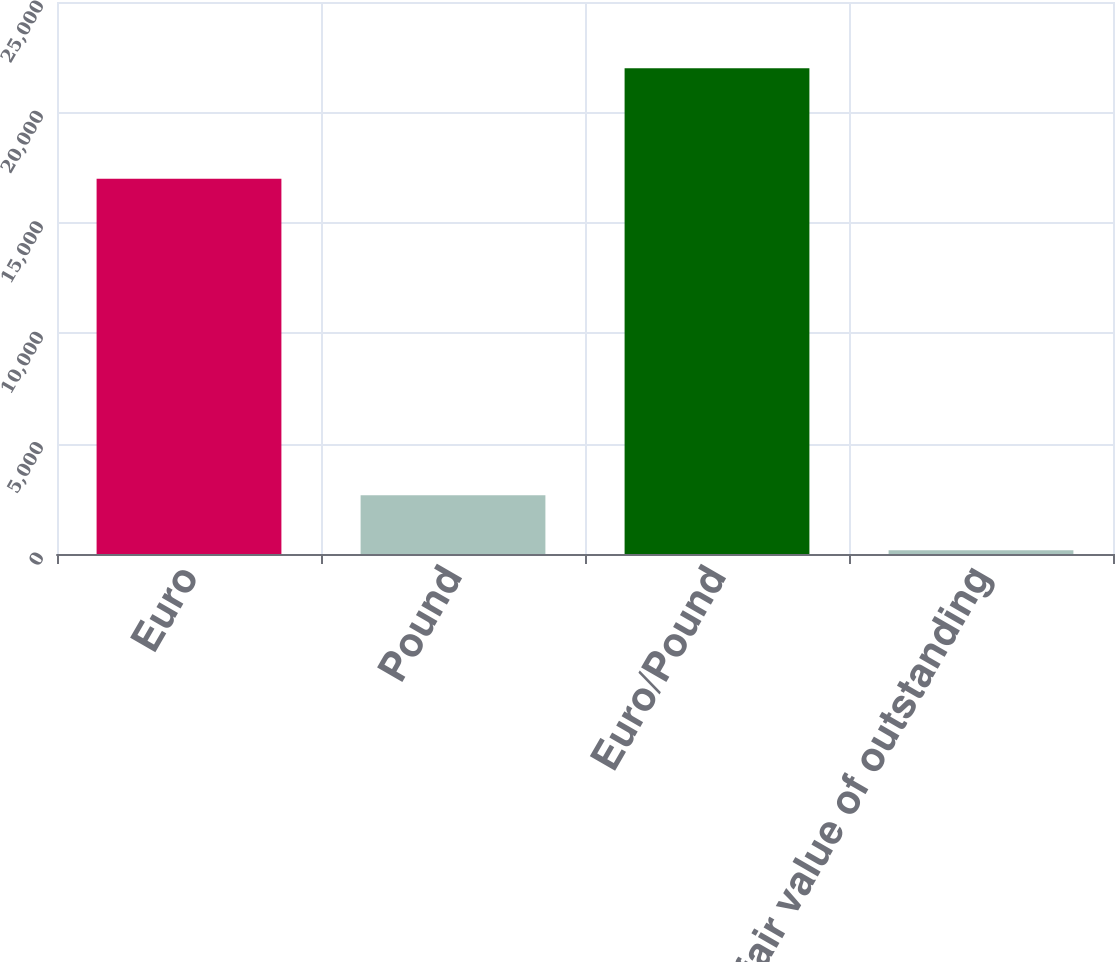Convert chart. <chart><loc_0><loc_0><loc_500><loc_500><bar_chart><fcel>Euro<fcel>Pound<fcel>Euro/Pound<fcel>Net fair value of outstanding<nl><fcel>17000<fcel>2660<fcel>22000<fcel>172<nl></chart> 